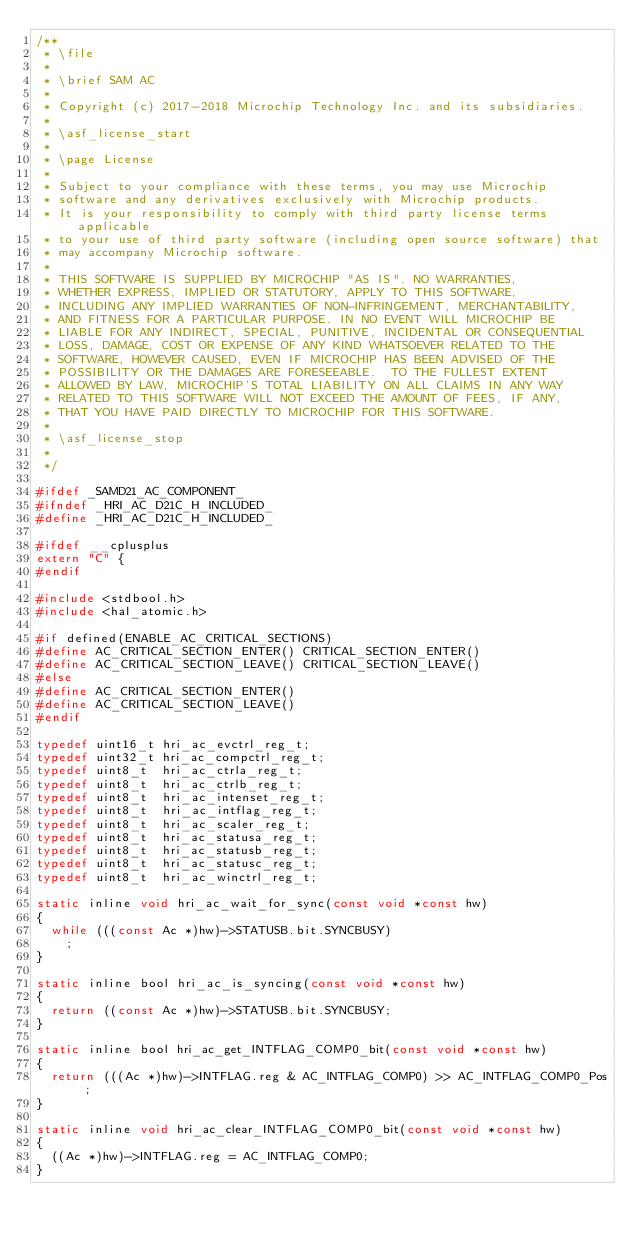<code> <loc_0><loc_0><loc_500><loc_500><_C_>/**
 * \file
 *
 * \brief SAM AC
 *
 * Copyright (c) 2017-2018 Microchip Technology Inc. and its subsidiaries.
 *
 * \asf_license_start
 *
 * \page License
 *
 * Subject to your compliance with these terms, you may use Microchip
 * software and any derivatives exclusively with Microchip products.
 * It is your responsibility to comply with third party license terms applicable
 * to your use of third party software (including open source software) that
 * may accompany Microchip software.
 *
 * THIS SOFTWARE IS SUPPLIED BY MICROCHIP "AS IS". NO WARRANTIES,
 * WHETHER EXPRESS, IMPLIED OR STATUTORY, APPLY TO THIS SOFTWARE,
 * INCLUDING ANY IMPLIED WARRANTIES OF NON-INFRINGEMENT, MERCHANTABILITY,
 * AND FITNESS FOR A PARTICULAR PURPOSE. IN NO EVENT WILL MICROCHIP BE
 * LIABLE FOR ANY INDIRECT, SPECIAL, PUNITIVE, INCIDENTAL OR CONSEQUENTIAL
 * LOSS, DAMAGE, COST OR EXPENSE OF ANY KIND WHATSOEVER RELATED TO THE
 * SOFTWARE, HOWEVER CAUSED, EVEN IF MICROCHIP HAS BEEN ADVISED OF THE
 * POSSIBILITY OR THE DAMAGES ARE FORESEEABLE.  TO THE FULLEST EXTENT
 * ALLOWED BY LAW, MICROCHIP'S TOTAL LIABILITY ON ALL CLAIMS IN ANY WAY
 * RELATED TO THIS SOFTWARE WILL NOT EXCEED THE AMOUNT OF FEES, IF ANY,
 * THAT YOU HAVE PAID DIRECTLY TO MICROCHIP FOR THIS SOFTWARE.
 *
 * \asf_license_stop
 *
 */

#ifdef _SAMD21_AC_COMPONENT_
#ifndef _HRI_AC_D21C_H_INCLUDED_
#define _HRI_AC_D21C_H_INCLUDED_

#ifdef __cplusplus
extern "C" {
#endif

#include <stdbool.h>
#include <hal_atomic.h>

#if defined(ENABLE_AC_CRITICAL_SECTIONS)
#define AC_CRITICAL_SECTION_ENTER() CRITICAL_SECTION_ENTER()
#define AC_CRITICAL_SECTION_LEAVE() CRITICAL_SECTION_LEAVE()
#else
#define AC_CRITICAL_SECTION_ENTER()
#define AC_CRITICAL_SECTION_LEAVE()
#endif

typedef uint16_t hri_ac_evctrl_reg_t;
typedef uint32_t hri_ac_compctrl_reg_t;
typedef uint8_t  hri_ac_ctrla_reg_t;
typedef uint8_t  hri_ac_ctrlb_reg_t;
typedef uint8_t  hri_ac_intenset_reg_t;
typedef uint8_t  hri_ac_intflag_reg_t;
typedef uint8_t  hri_ac_scaler_reg_t;
typedef uint8_t  hri_ac_statusa_reg_t;
typedef uint8_t  hri_ac_statusb_reg_t;
typedef uint8_t  hri_ac_statusc_reg_t;
typedef uint8_t  hri_ac_winctrl_reg_t;

static inline void hri_ac_wait_for_sync(const void *const hw)
{
	while (((const Ac *)hw)->STATUSB.bit.SYNCBUSY)
		;
}

static inline bool hri_ac_is_syncing(const void *const hw)
{
	return ((const Ac *)hw)->STATUSB.bit.SYNCBUSY;
}

static inline bool hri_ac_get_INTFLAG_COMP0_bit(const void *const hw)
{
	return (((Ac *)hw)->INTFLAG.reg & AC_INTFLAG_COMP0) >> AC_INTFLAG_COMP0_Pos;
}

static inline void hri_ac_clear_INTFLAG_COMP0_bit(const void *const hw)
{
	((Ac *)hw)->INTFLAG.reg = AC_INTFLAG_COMP0;
}
</code> 